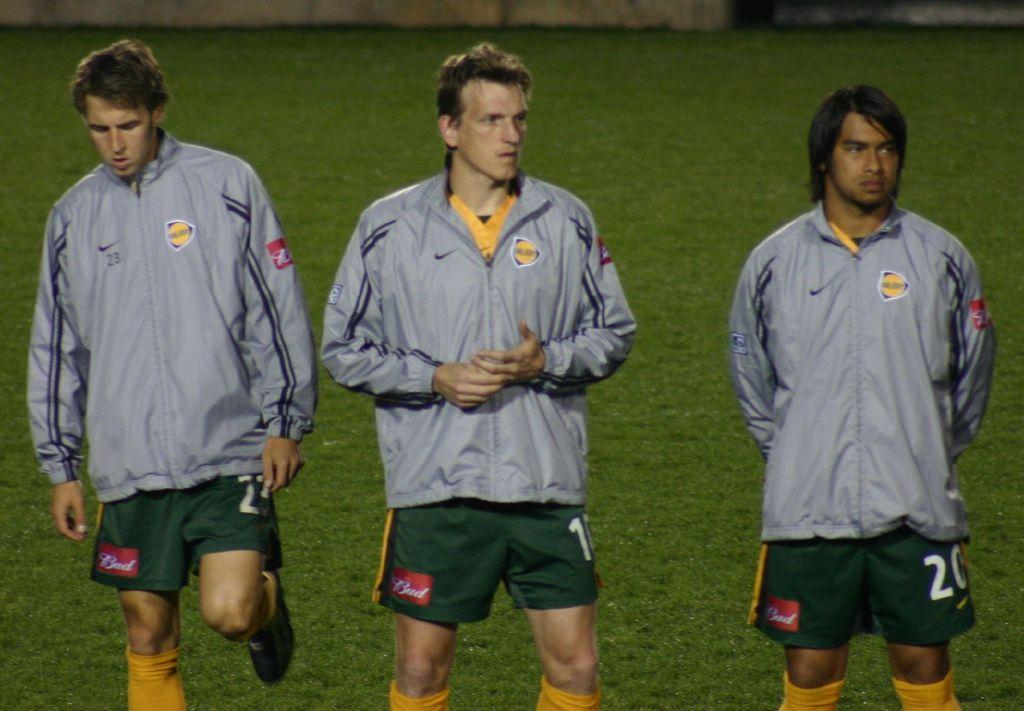How many people are in the image? There are three men in the image. What are the men doing in the image? The men are standing in the image. What type of clothing are the men wearing on their upper bodies? The men are wearing jackets in the image. What type of clothing are the men wearing on their lower bodies? The men are wearing shorts in the image. What is the ground covered with in the image? There is grass on the ground in the image. Can you see any smoke coming from the men's cigarettes in the image? There is no indication of cigarettes or smoke in the image. How far away is the pig from the men in the image? There is no pig present in the image. 